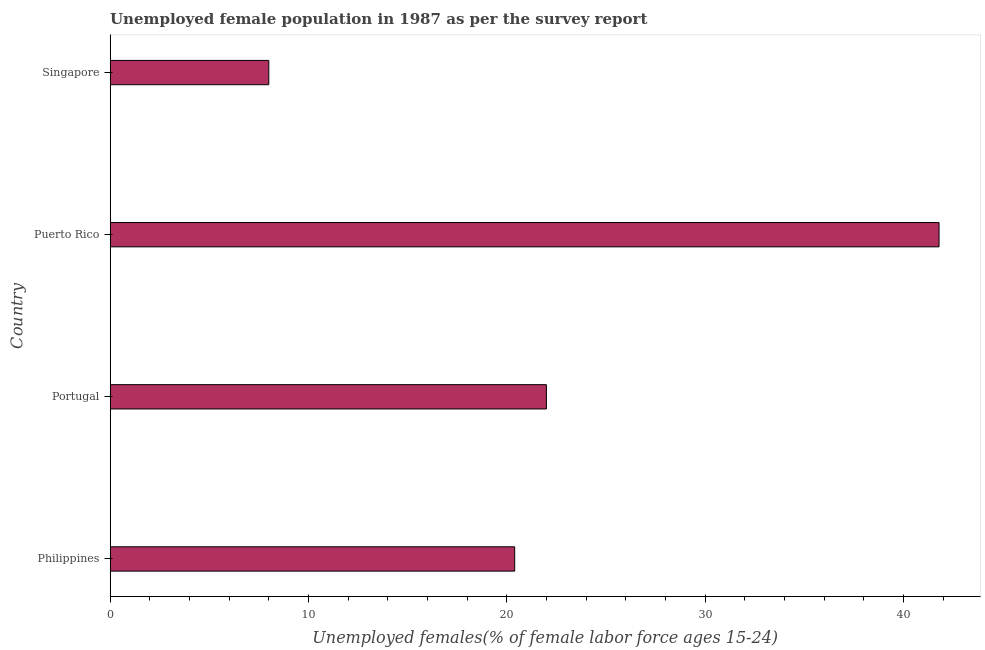Does the graph contain any zero values?
Keep it short and to the point. No. Does the graph contain grids?
Your answer should be compact. No. What is the title of the graph?
Keep it short and to the point. Unemployed female population in 1987 as per the survey report. What is the label or title of the X-axis?
Give a very brief answer. Unemployed females(% of female labor force ages 15-24). Across all countries, what is the maximum unemployed female youth?
Your answer should be compact. 41.8. In which country was the unemployed female youth maximum?
Provide a short and direct response. Puerto Rico. In which country was the unemployed female youth minimum?
Keep it short and to the point. Singapore. What is the sum of the unemployed female youth?
Ensure brevity in your answer.  92.2. What is the difference between the unemployed female youth in Philippines and Puerto Rico?
Give a very brief answer. -21.4. What is the average unemployed female youth per country?
Make the answer very short. 23.05. What is the median unemployed female youth?
Make the answer very short. 21.2. What is the ratio of the unemployed female youth in Philippines to that in Singapore?
Offer a very short reply. 2.55. Is the difference between the unemployed female youth in Philippines and Puerto Rico greater than the difference between any two countries?
Give a very brief answer. No. What is the difference between the highest and the second highest unemployed female youth?
Your response must be concise. 19.8. Is the sum of the unemployed female youth in Philippines and Singapore greater than the maximum unemployed female youth across all countries?
Your answer should be very brief. No. What is the difference between the highest and the lowest unemployed female youth?
Your response must be concise. 33.8. In how many countries, is the unemployed female youth greater than the average unemployed female youth taken over all countries?
Give a very brief answer. 1. How many bars are there?
Give a very brief answer. 4. How many countries are there in the graph?
Keep it short and to the point. 4. What is the difference between two consecutive major ticks on the X-axis?
Your answer should be compact. 10. Are the values on the major ticks of X-axis written in scientific E-notation?
Give a very brief answer. No. What is the Unemployed females(% of female labor force ages 15-24) of Philippines?
Offer a terse response. 20.4. What is the Unemployed females(% of female labor force ages 15-24) in Puerto Rico?
Your answer should be very brief. 41.8. What is the difference between the Unemployed females(% of female labor force ages 15-24) in Philippines and Puerto Rico?
Your answer should be compact. -21.4. What is the difference between the Unemployed females(% of female labor force ages 15-24) in Portugal and Puerto Rico?
Keep it short and to the point. -19.8. What is the difference between the Unemployed females(% of female labor force ages 15-24) in Portugal and Singapore?
Provide a succinct answer. 14. What is the difference between the Unemployed females(% of female labor force ages 15-24) in Puerto Rico and Singapore?
Your response must be concise. 33.8. What is the ratio of the Unemployed females(% of female labor force ages 15-24) in Philippines to that in Portugal?
Provide a short and direct response. 0.93. What is the ratio of the Unemployed females(% of female labor force ages 15-24) in Philippines to that in Puerto Rico?
Your answer should be compact. 0.49. What is the ratio of the Unemployed females(% of female labor force ages 15-24) in Philippines to that in Singapore?
Your answer should be compact. 2.55. What is the ratio of the Unemployed females(% of female labor force ages 15-24) in Portugal to that in Puerto Rico?
Give a very brief answer. 0.53. What is the ratio of the Unemployed females(% of female labor force ages 15-24) in Portugal to that in Singapore?
Offer a very short reply. 2.75. What is the ratio of the Unemployed females(% of female labor force ages 15-24) in Puerto Rico to that in Singapore?
Give a very brief answer. 5.22. 